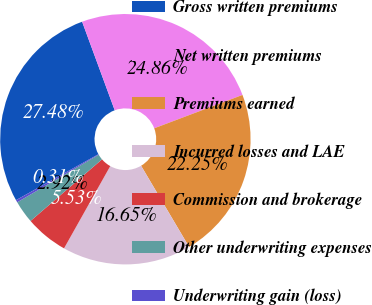Convert chart. <chart><loc_0><loc_0><loc_500><loc_500><pie_chart><fcel>Gross written premiums<fcel>Net written premiums<fcel>Premiums earned<fcel>Incurred losses and LAE<fcel>Commission and brokerage<fcel>Other underwriting expenses<fcel>Underwriting gain (loss)<nl><fcel>27.48%<fcel>24.86%<fcel>22.25%<fcel>16.65%<fcel>5.53%<fcel>2.92%<fcel>0.31%<nl></chart> 